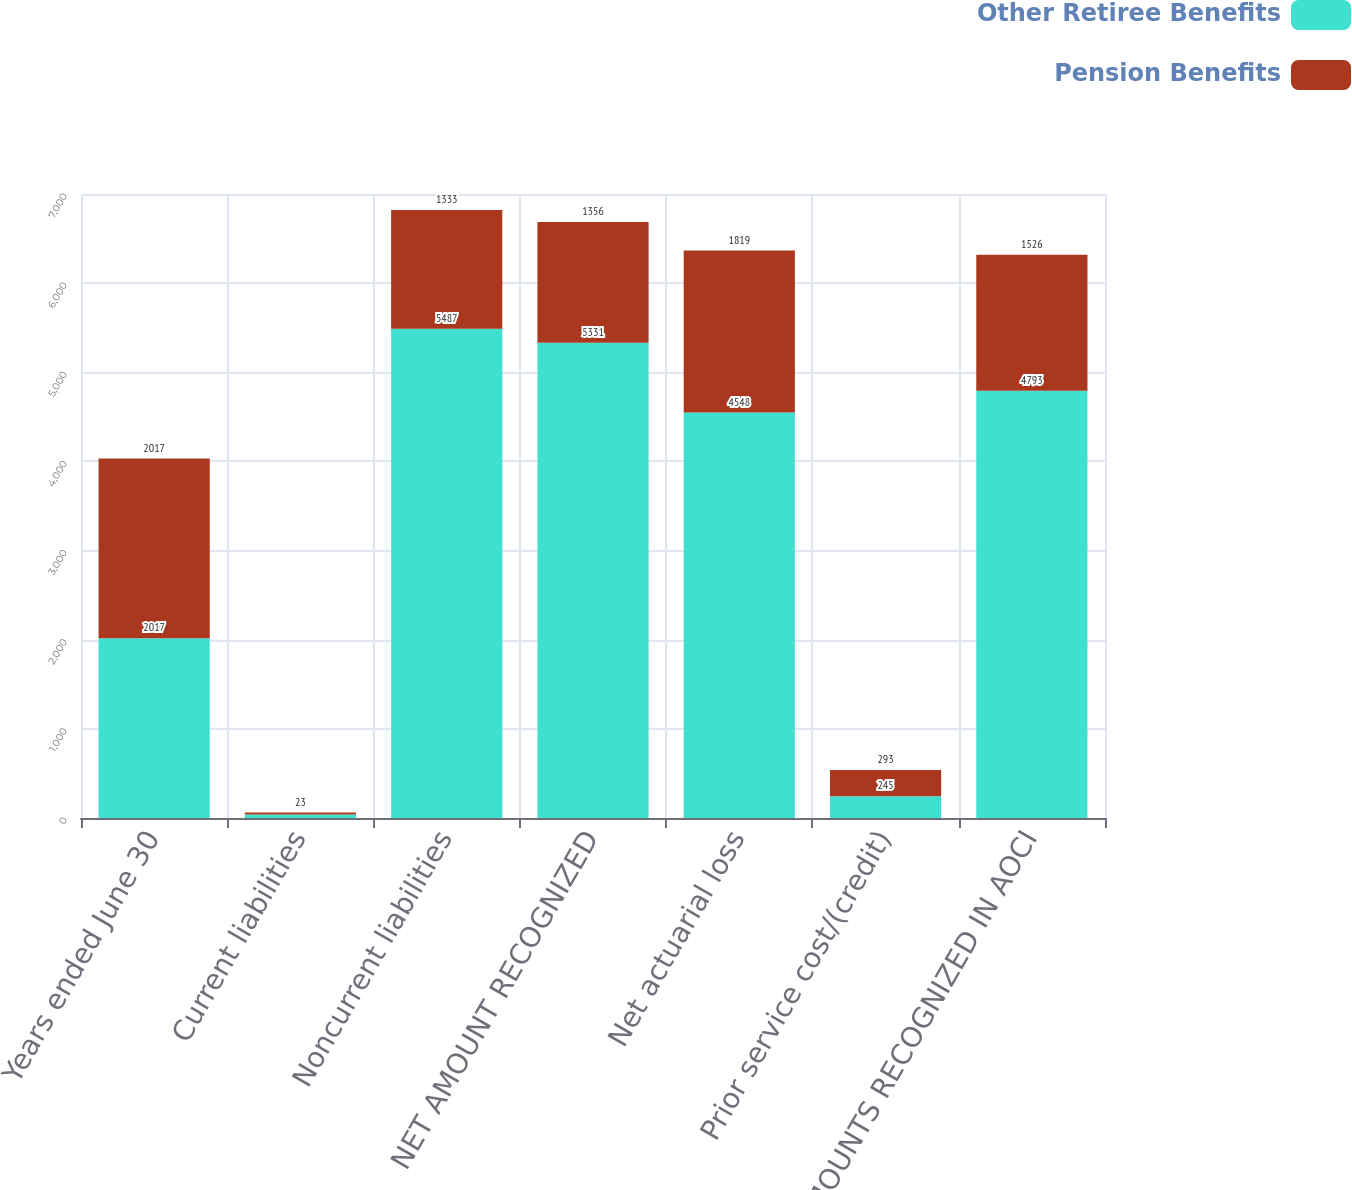<chart> <loc_0><loc_0><loc_500><loc_500><stacked_bar_chart><ecel><fcel>Years ended June 30<fcel>Current liabilities<fcel>Noncurrent liabilities<fcel>NET AMOUNT RECOGNIZED<fcel>Net actuarial loss<fcel>Prior service cost/(credit)<fcel>NET AMOUNTS RECOGNIZED IN AOCI<nl><fcel>Other Retiree Benefits<fcel>2017<fcel>40<fcel>5487<fcel>5331<fcel>4548<fcel>245<fcel>4793<nl><fcel>Pension Benefits<fcel>2017<fcel>23<fcel>1333<fcel>1356<fcel>1819<fcel>293<fcel>1526<nl></chart> 